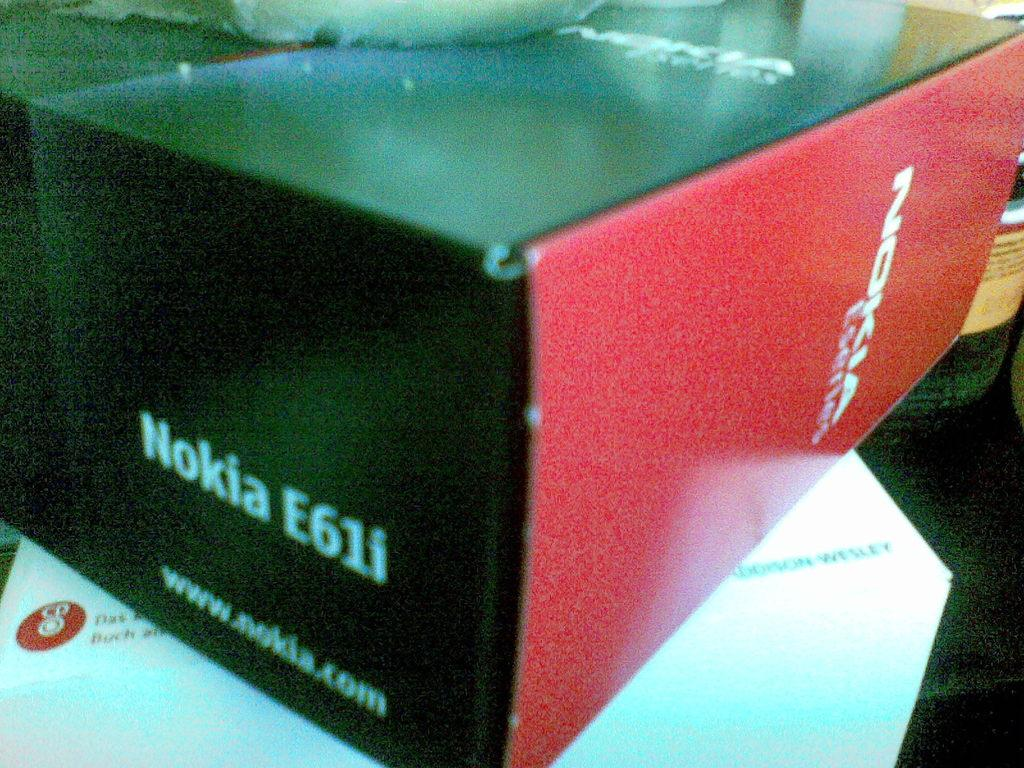<image>
Describe the image concisely. A red and black Nokia E61i cell phone box. 